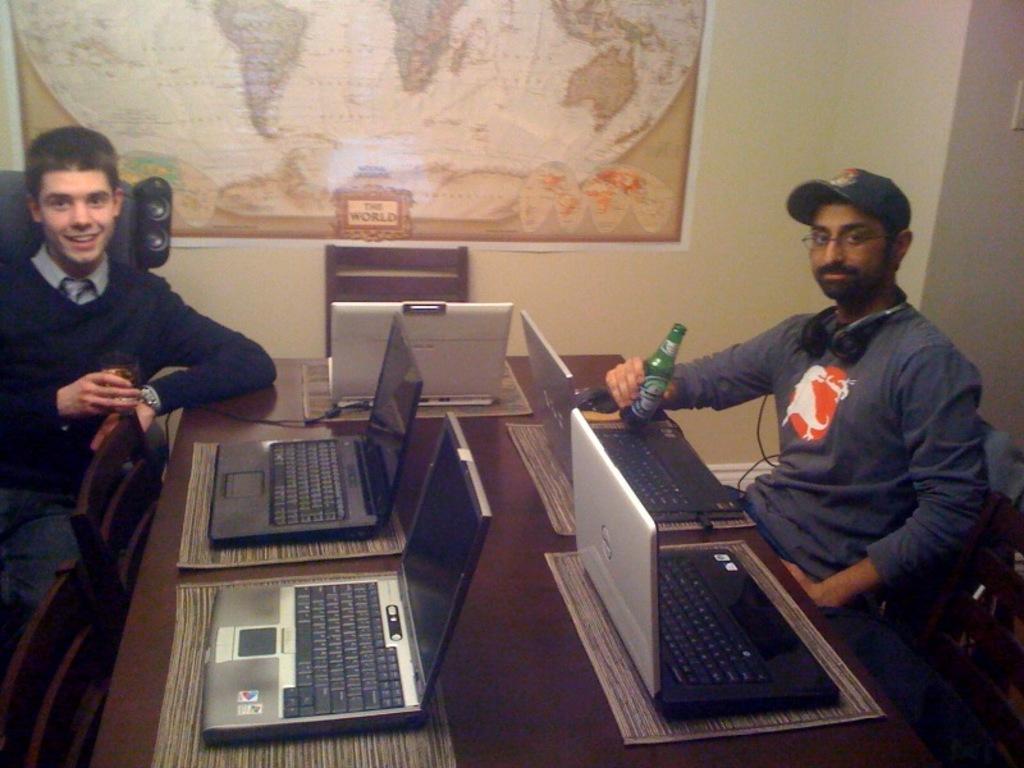Could you give a brief overview of what you see in this image? There are two people sitting in front of a table, there are laptops on the table. There is a map and a chair in the background. 